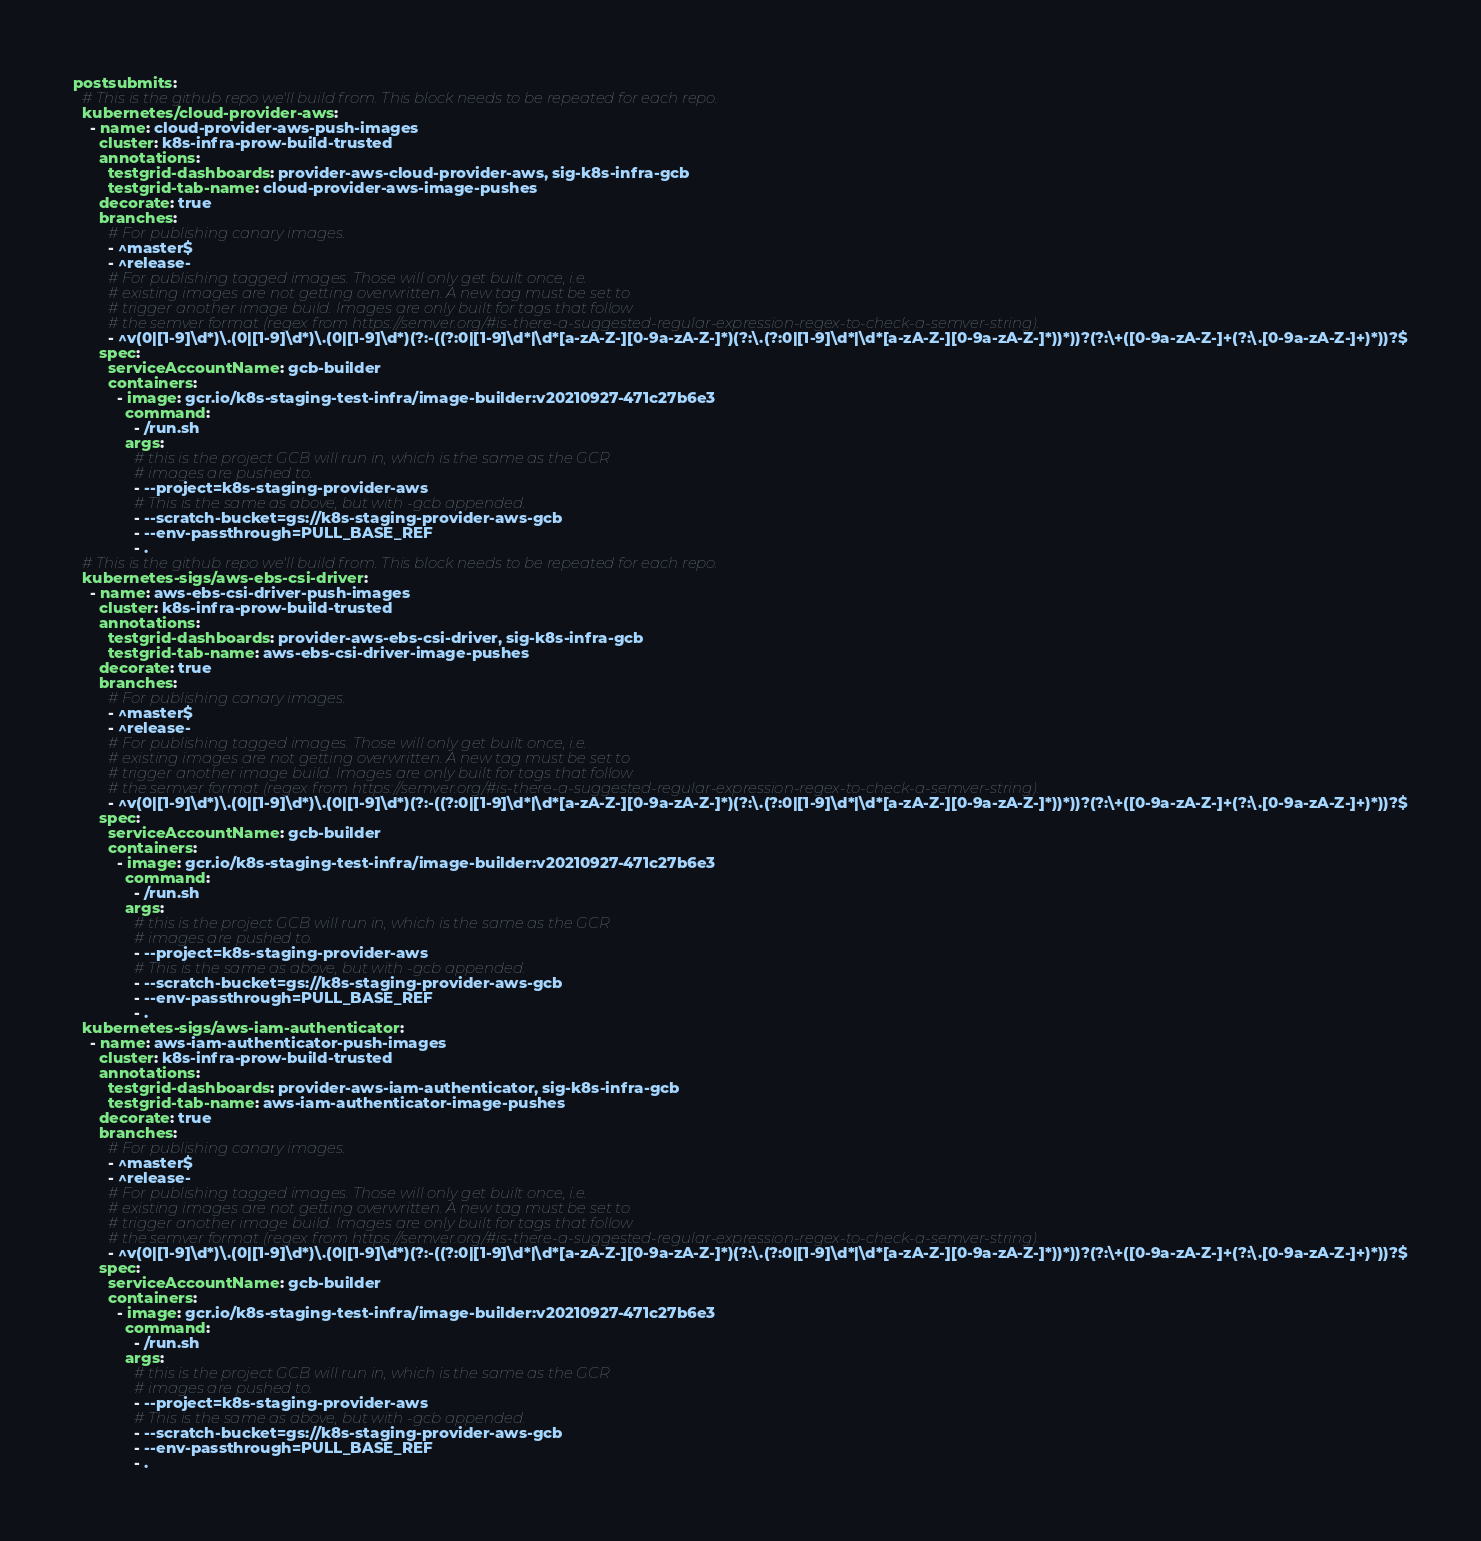Convert code to text. <code><loc_0><loc_0><loc_500><loc_500><_YAML_>postsubmits:
  # This is the github repo we'll build from. This block needs to be repeated for each repo.
  kubernetes/cloud-provider-aws:
    - name: cloud-provider-aws-push-images
      cluster: k8s-infra-prow-build-trusted
      annotations:
        testgrid-dashboards: provider-aws-cloud-provider-aws, sig-k8s-infra-gcb
        testgrid-tab-name: cloud-provider-aws-image-pushes
      decorate: true
      branches:
        # For publishing canary images.
        - ^master$
        - ^release-
        # For publishing tagged images. Those will only get built once, i.e.
        # existing images are not getting overwritten. A new tag must be set to
        # trigger another image build. Images are only built for tags that follow
        # the semver format (regex from https://semver.org/#is-there-a-suggested-regular-expression-regex-to-check-a-semver-string).
        - ^v(0|[1-9]\d*)\.(0|[1-9]\d*)\.(0|[1-9]\d*)(?:-((?:0|[1-9]\d*|\d*[a-zA-Z-][0-9a-zA-Z-]*)(?:\.(?:0|[1-9]\d*|\d*[a-zA-Z-][0-9a-zA-Z-]*))*))?(?:\+([0-9a-zA-Z-]+(?:\.[0-9a-zA-Z-]+)*))?$
      spec:
        serviceAccountName: gcb-builder
        containers:
          - image: gcr.io/k8s-staging-test-infra/image-builder:v20210927-471c27b6e3
            command:
              - /run.sh
            args:
              # this is the project GCB will run in, which is the same as the GCR
              # images are pushed to.
              - --project=k8s-staging-provider-aws
              # This is the same as above, but with -gcb appended.
              - --scratch-bucket=gs://k8s-staging-provider-aws-gcb
              - --env-passthrough=PULL_BASE_REF
              - .
  # This is the github repo we'll build from. This block needs to be repeated for each repo.
  kubernetes-sigs/aws-ebs-csi-driver:
    - name: aws-ebs-csi-driver-push-images
      cluster: k8s-infra-prow-build-trusted
      annotations:
        testgrid-dashboards: provider-aws-ebs-csi-driver, sig-k8s-infra-gcb
        testgrid-tab-name: aws-ebs-csi-driver-image-pushes
      decorate: true
      branches:
        # For publishing canary images.
        - ^master$
        - ^release-
        # For publishing tagged images. Those will only get built once, i.e.
        # existing images are not getting overwritten. A new tag must be set to
        # trigger another image build. Images are only built for tags that follow
        # the semver format (regex from https://semver.org/#is-there-a-suggested-regular-expression-regex-to-check-a-semver-string).
        - ^v(0|[1-9]\d*)\.(0|[1-9]\d*)\.(0|[1-9]\d*)(?:-((?:0|[1-9]\d*|\d*[a-zA-Z-][0-9a-zA-Z-]*)(?:\.(?:0|[1-9]\d*|\d*[a-zA-Z-][0-9a-zA-Z-]*))*))?(?:\+([0-9a-zA-Z-]+(?:\.[0-9a-zA-Z-]+)*))?$
      spec:
        serviceAccountName: gcb-builder
        containers:
          - image: gcr.io/k8s-staging-test-infra/image-builder:v20210927-471c27b6e3
            command:
              - /run.sh
            args:
              # this is the project GCB will run in, which is the same as the GCR
              # images are pushed to.
              - --project=k8s-staging-provider-aws
              # This is the same as above, but with -gcb appended.
              - --scratch-bucket=gs://k8s-staging-provider-aws-gcb
              - --env-passthrough=PULL_BASE_REF
              - .
  kubernetes-sigs/aws-iam-authenticator:
    - name: aws-iam-authenticator-push-images
      cluster: k8s-infra-prow-build-trusted
      annotations:
        testgrid-dashboards: provider-aws-iam-authenticator, sig-k8s-infra-gcb
        testgrid-tab-name: aws-iam-authenticator-image-pushes
      decorate: true
      branches:
        # For publishing canary images.
        - ^master$
        - ^release-
        # For publishing tagged images. Those will only get built once, i.e.
        # existing images are not getting overwritten. A new tag must be set to
        # trigger another image build. Images are only built for tags that follow
        # the semver format (regex from https://semver.org/#is-there-a-suggested-regular-expression-regex-to-check-a-semver-string).
        - ^v(0|[1-9]\d*)\.(0|[1-9]\d*)\.(0|[1-9]\d*)(?:-((?:0|[1-9]\d*|\d*[a-zA-Z-][0-9a-zA-Z-]*)(?:\.(?:0|[1-9]\d*|\d*[a-zA-Z-][0-9a-zA-Z-]*))*))?(?:\+([0-9a-zA-Z-]+(?:\.[0-9a-zA-Z-]+)*))?$
      spec:
        serviceAccountName: gcb-builder
        containers:
          - image: gcr.io/k8s-staging-test-infra/image-builder:v20210927-471c27b6e3
            command:
              - /run.sh
            args:
              # this is the project GCB will run in, which is the same as the GCR
              # images are pushed to.
              - --project=k8s-staging-provider-aws
              # This is the same as above, but with -gcb appended.
              - --scratch-bucket=gs://k8s-staging-provider-aws-gcb
              - --env-passthrough=PULL_BASE_REF
              - .
</code> 